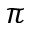<formula> <loc_0><loc_0><loc_500><loc_500>\pi</formula> 